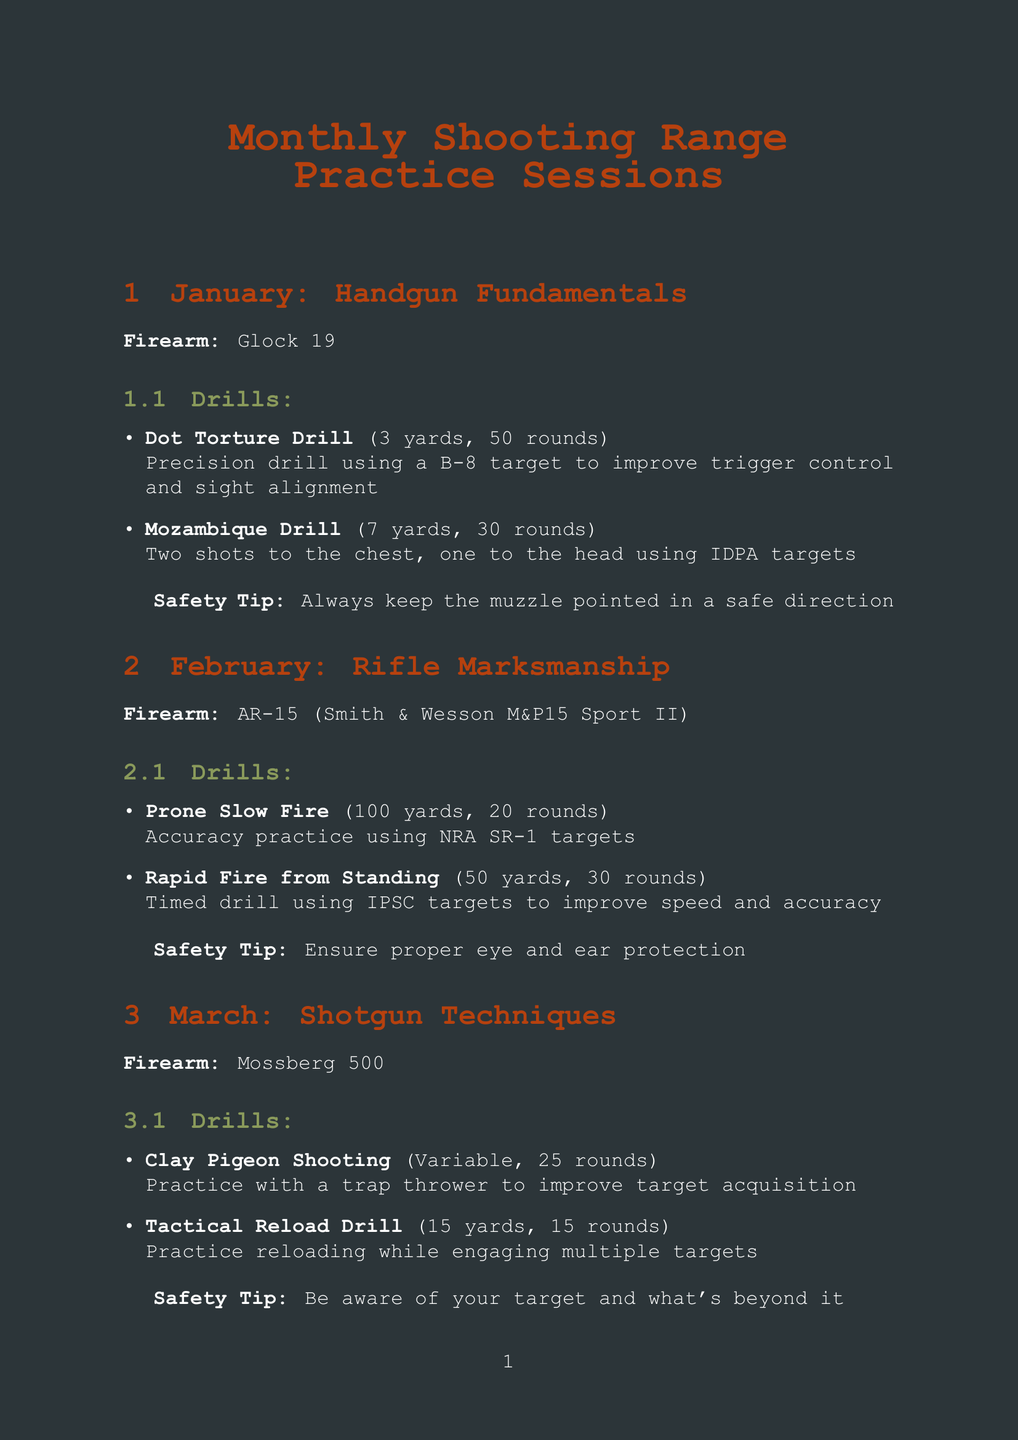What is the focus for January? The focus for January is the theme highlighted in the document for that month, which is Handgun Fundamentals.
Answer: Handgun Fundamentals How many rounds are needed for the Mozambique Drill? This is the number of rounds required for that specific drill listed in January's schedule.
Answer: 30 What firearm is used during the Clay Pigeon Shooting drill? This question asks for the specific firearm associated with the drill in March.
Answer: Mossberg 500 What safety tip is provided for the April session? The safety tip associated with the activities scheduled for April involving long range precision is specified in the document.
Answer: Always treat every firearm as if it were loaded In which month is the Draw and Fire Drill practiced? The month when the Draw and Fire Drill is scheduled is found in the May section of the document.
Answer: May What is the maximum distance for drills in June? This question is directed toward the maximum distance a drill can cover in June's competition preparation activities.
Answer: 25 yards How many rounds are there for the Positional Shooting drill? This reflects the total number of rounds you need to perform the Positional Shooting drill, as indicated in April.
Answer: 30 What is the primary firearm used for February's session? This question seeks to identify the firearm that is crucial for practice in February’s Rifle Marksmanship session.
Answer: AR-15 (Smith & Wesson M&P15 Sport II) 